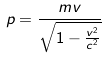<formula> <loc_0><loc_0><loc_500><loc_500>p = \frac { m v } { \sqrt { 1 - \frac { v ^ { 2 } } { c ^ { 2 } } } }</formula> 